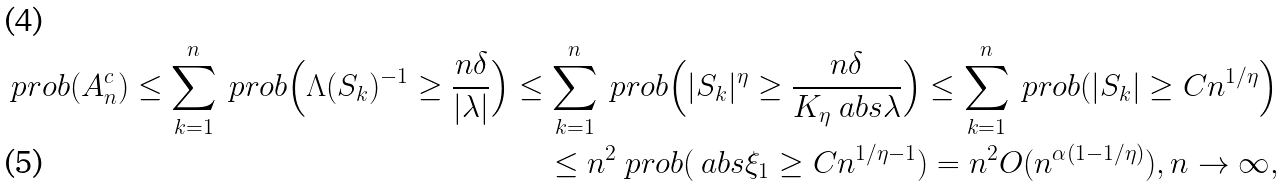Convert formula to latex. <formula><loc_0><loc_0><loc_500><loc_500>\ p r o b ( A _ { n } ^ { c } ) \leq \sum _ { k = 1 } ^ { n } \ p r o b \Big ( \Lambda ( S _ { k } ) ^ { - 1 } \geq \frac { n \delta } { | \lambda | } \Big ) \leq \sum _ { k = 1 } ^ { n } \ p r o b \Big ( | S _ { k } | ^ { \eta } \geq \frac { n \delta } { K _ { \eta } \ a b s { \lambda } } \Big ) \leq \sum _ { k = 1 } ^ { n } \ p r o b ( | S _ { k } | \geq C n ^ { 1 / \eta } \Big ) \\ \leq n ^ { 2 } \ p r o b ( \ a b s { \xi _ { 1 } } \geq C n ^ { 1 / \eta - 1 } ) = n ^ { 2 } O ( n ^ { \alpha ( 1 - 1 / \eta ) } ) , n \to \infty ,</formula> 